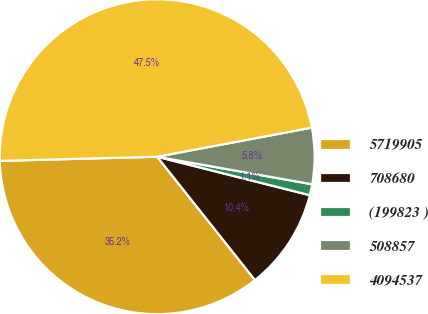<chart> <loc_0><loc_0><loc_500><loc_500><pie_chart><fcel>5719905<fcel>708680<fcel>(199823 )<fcel>508857<fcel>4094537<nl><fcel>35.25%<fcel>10.4%<fcel>1.13%<fcel>5.76%<fcel>47.47%<nl></chart> 